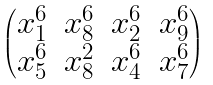Convert formula to latex. <formula><loc_0><loc_0><loc_500><loc_500>\begin{pmatrix} x _ { 1 } ^ { 6 } & x _ { 8 } ^ { 6 } & x _ { 2 } ^ { 6 } & x _ { 9 } ^ { 6 } \\ x _ { 5 } ^ { 6 } & x _ { 8 } ^ { 2 } & x _ { 4 } ^ { 6 } & x _ { 7 } ^ { 6 } \end{pmatrix}</formula> 